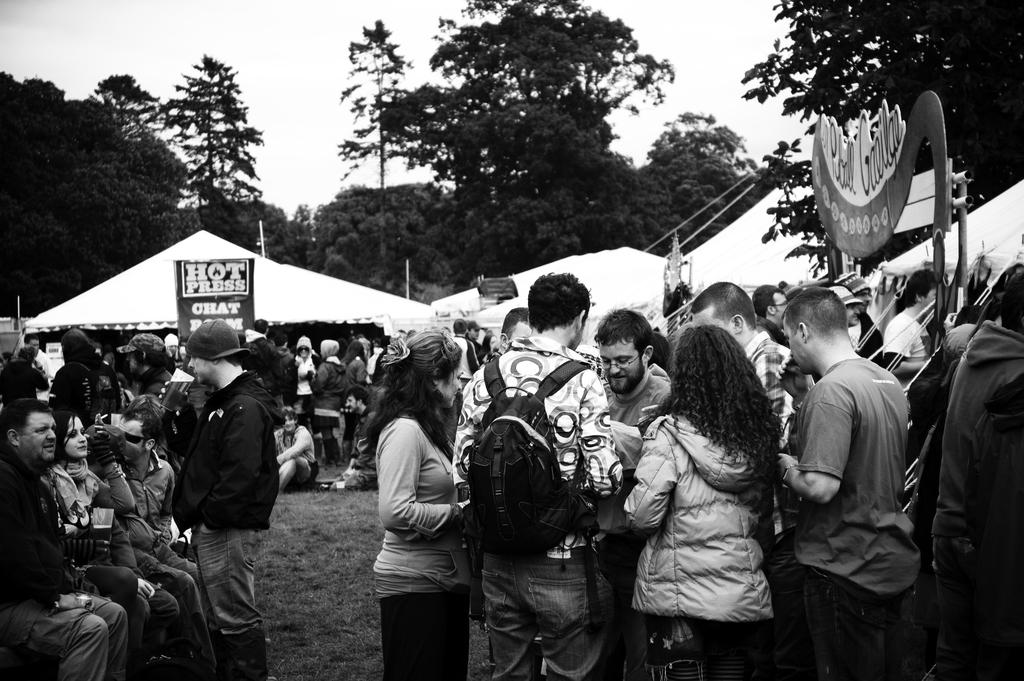What are the people in the center of the image doing? Some people are sitting, and some are standing in the center of the image. What can be seen in the background of the image? There are tents, boards, and trees in the background of the image. What is visible at the top of the image? The sky is visible at the top of the image. What type of tank can be seen in the image? There is no tank present in the image. What is the interest rate of the loan mentioned in the image? There is no mention of a loan or interest rate in the image. 